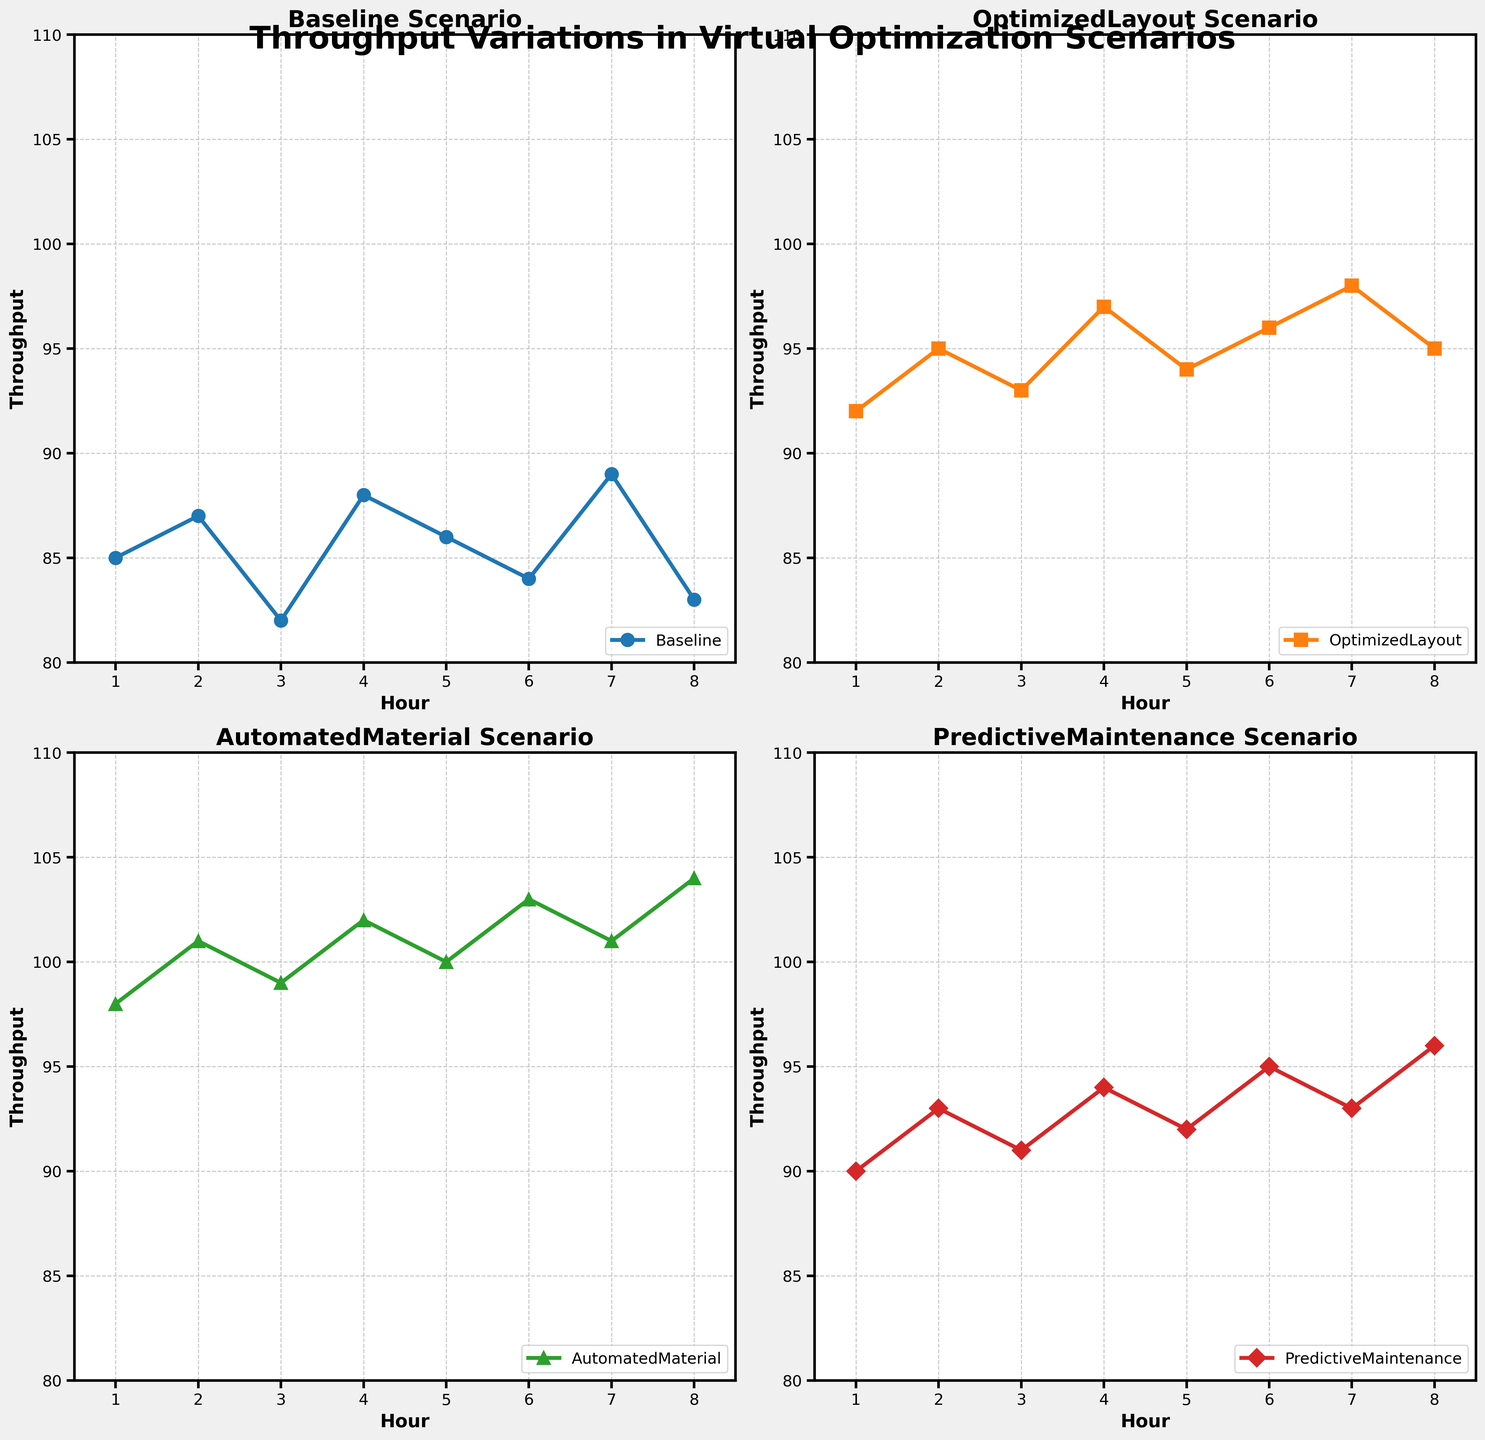What's the average throughput in the Baseline scenario? The Baseline scenario has throughput values of 85, 87, 82, 88, 86, 84, 89, and 83. Summing them up gives 684. There are 8 data points, so the average throughput is 684/8 = 85.5
Answer: 85.5 Which scenario shows the highest throughput in Hour 4? We locate Hour 4 on all four subplots and compare the throughput values. Baseline has 88, OptimizedLayout has 97, AutomatedMaterial has 102, and PredictiveMaintenance has 94. The highest value is 102 in the AutomatedMaterial scenario
Answer: AutomatedMaterial By how much does the throughput increase from Hour 1 to Hour 8 in the PredictiveMaintenance scenario? In the PredictiveMaintenance subplot, the throughput at Hour 1 is 90 and at Hour 8 it is 96. The increase is found by subtracting the two values: 96 - 90 = 6
Answer: 6 Which two scenarios have the closest average throughput values? Calculate the average throughput for each scenario. Baseline: 85.5, OptimizedLayout: 95.125, AutomatedMaterial: 101, PredictiveMaintenance: 92. The closest averages are Baseline (85.5) and PredictiveMaintenance (92). The difference is 92 - 85.5 = 6.5; OptimizedLayout and PredictiveMaintenance differ by 95.125 - 92 = 3.125, which is smaller
Answer: OptimizedLayout and PredictiveMaintenance What is the range of throughput values in the AutomatedMaterial scenario? The throughput values for AutomatedMaterial (98, 101, 99, 102, 100, 103, 101, 104) have a minimum of 98 and a maximum of 104. The range is calculated as 104 - 98 = 6
Answer: 6 Which scenario shows the most consistent throughput values over the hours? Consistency can be assessed by looking at the fluctuations or range of throughput values over the hours. The Baseline varies between 82 and 89 (7 units), OptimizedLayout varies between 92 and 98 (6 units), AutomatedMaterial varies between 98 and 104 (6 units), and PredictiveMaintenance between 90 and 96 (6 units). Baseline has the most variation with a range of 7 while the others have a range of 6. All scenarios except Baseline are equally consistent with a range of 6
Answer: OptimizedLayout, AutomatedMaterial, and PredictiveMaintenance How much higher is the maximum throughput of AutomatedMaterial compared to the maximum throughput of Baseline? Maximum throughput of AutomatedMaterial is 104, while that of Baseline is 89. The difference is calculated as 104 - 89 = 15
Answer: 15 